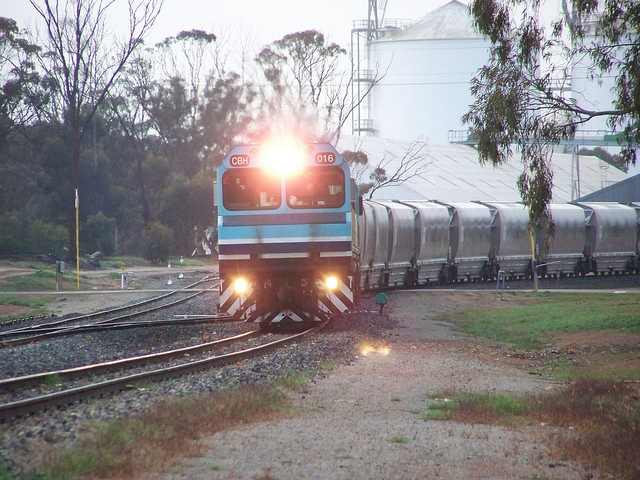Please extract the text content from this image. CBH 016 